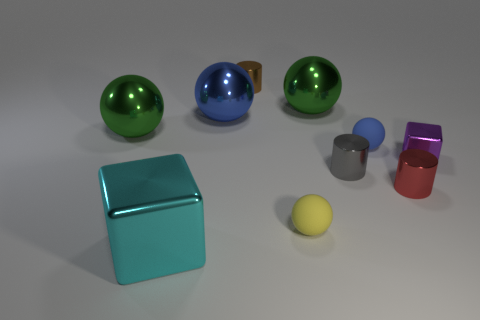Subtract all large blue metallic balls. How many balls are left? 4 Subtract all yellow balls. How many balls are left? 4 Subtract all cyan spheres. Subtract all red cubes. How many spheres are left? 5 Subtract all cubes. How many objects are left? 8 Subtract all big purple rubber cylinders. Subtract all big cyan things. How many objects are left? 9 Add 8 large blue metal spheres. How many large blue metal spheres are left? 9 Add 8 big blue spheres. How many big blue spheres exist? 9 Subtract 0 brown balls. How many objects are left? 10 